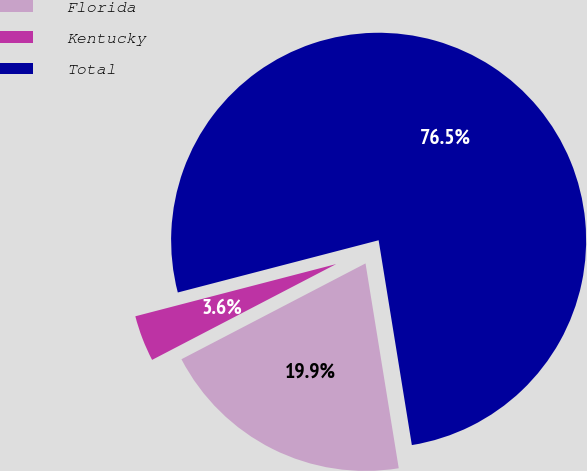Convert chart to OTSL. <chart><loc_0><loc_0><loc_500><loc_500><pie_chart><fcel>Florida<fcel>Kentucky<fcel>Total<nl><fcel>19.92%<fcel>3.59%<fcel>76.49%<nl></chart> 